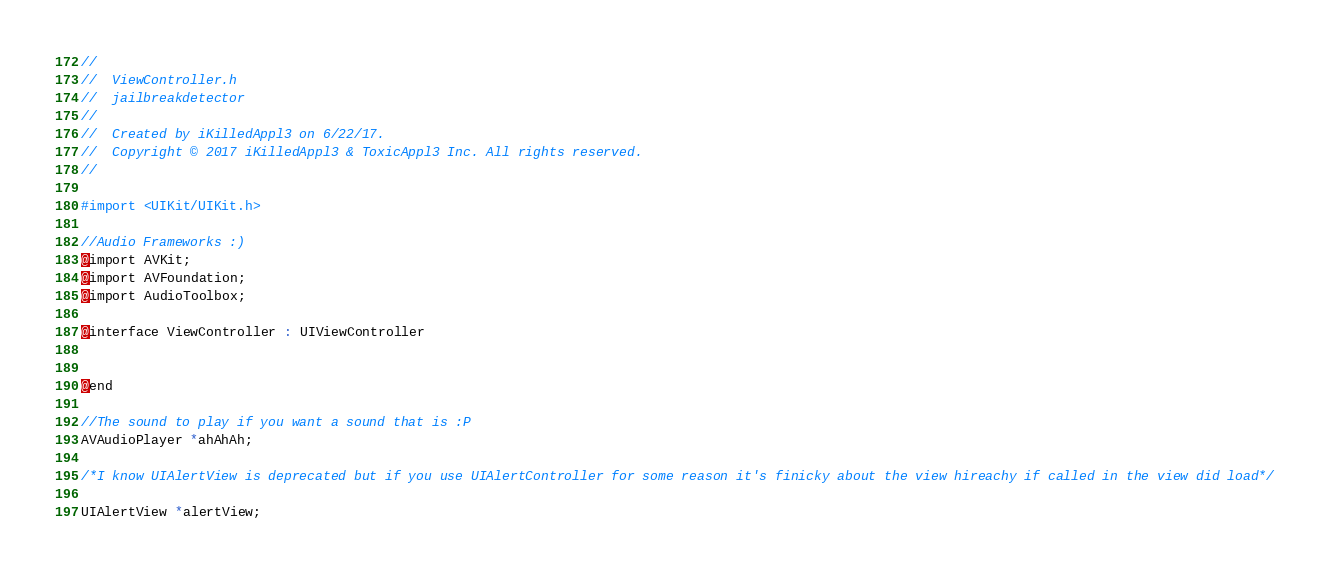Convert code to text. <code><loc_0><loc_0><loc_500><loc_500><_C_>//
//  ViewController.h
//  jailbreakdetector
//
//  Created by iKilledAppl3 on 6/22/17.
//  Copyright © 2017 iKilledAppl3 & ToxicAppl3 Inc. All rights reserved.
//

#import <UIKit/UIKit.h>

//Audio Frameworks :)
@import AVKit;
@import AVFoundation;
@import AudioToolbox;

@interface ViewController : UIViewController


@end

//The sound to play if you want a sound that is :P
AVAudioPlayer *ahAhAh;

/*I know UIAlertView is deprecated but if you use UIAlertController for some reason it's finicky about the view hireachy if called in the view did load*/

UIAlertView *alertView;

</code> 